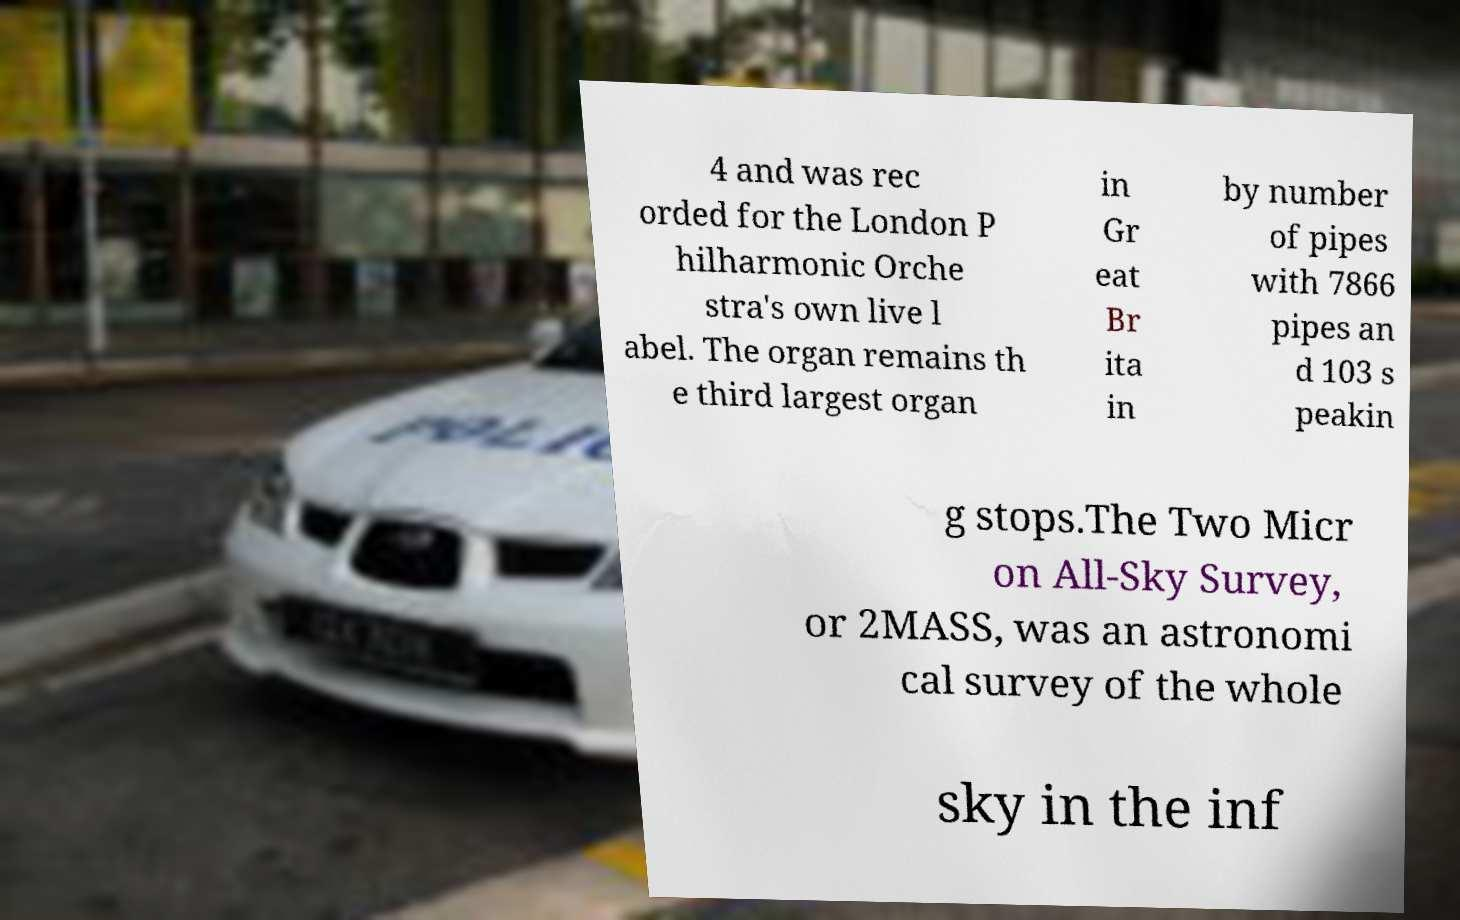Could you assist in decoding the text presented in this image and type it out clearly? 4 and was rec orded for the London P hilharmonic Orche stra's own live l abel. The organ remains th e third largest organ in Gr eat Br ita in by number of pipes with 7866 pipes an d 103 s peakin g stops.The Two Micr on All-Sky Survey, or 2MASS, was an astronomi cal survey of the whole sky in the inf 